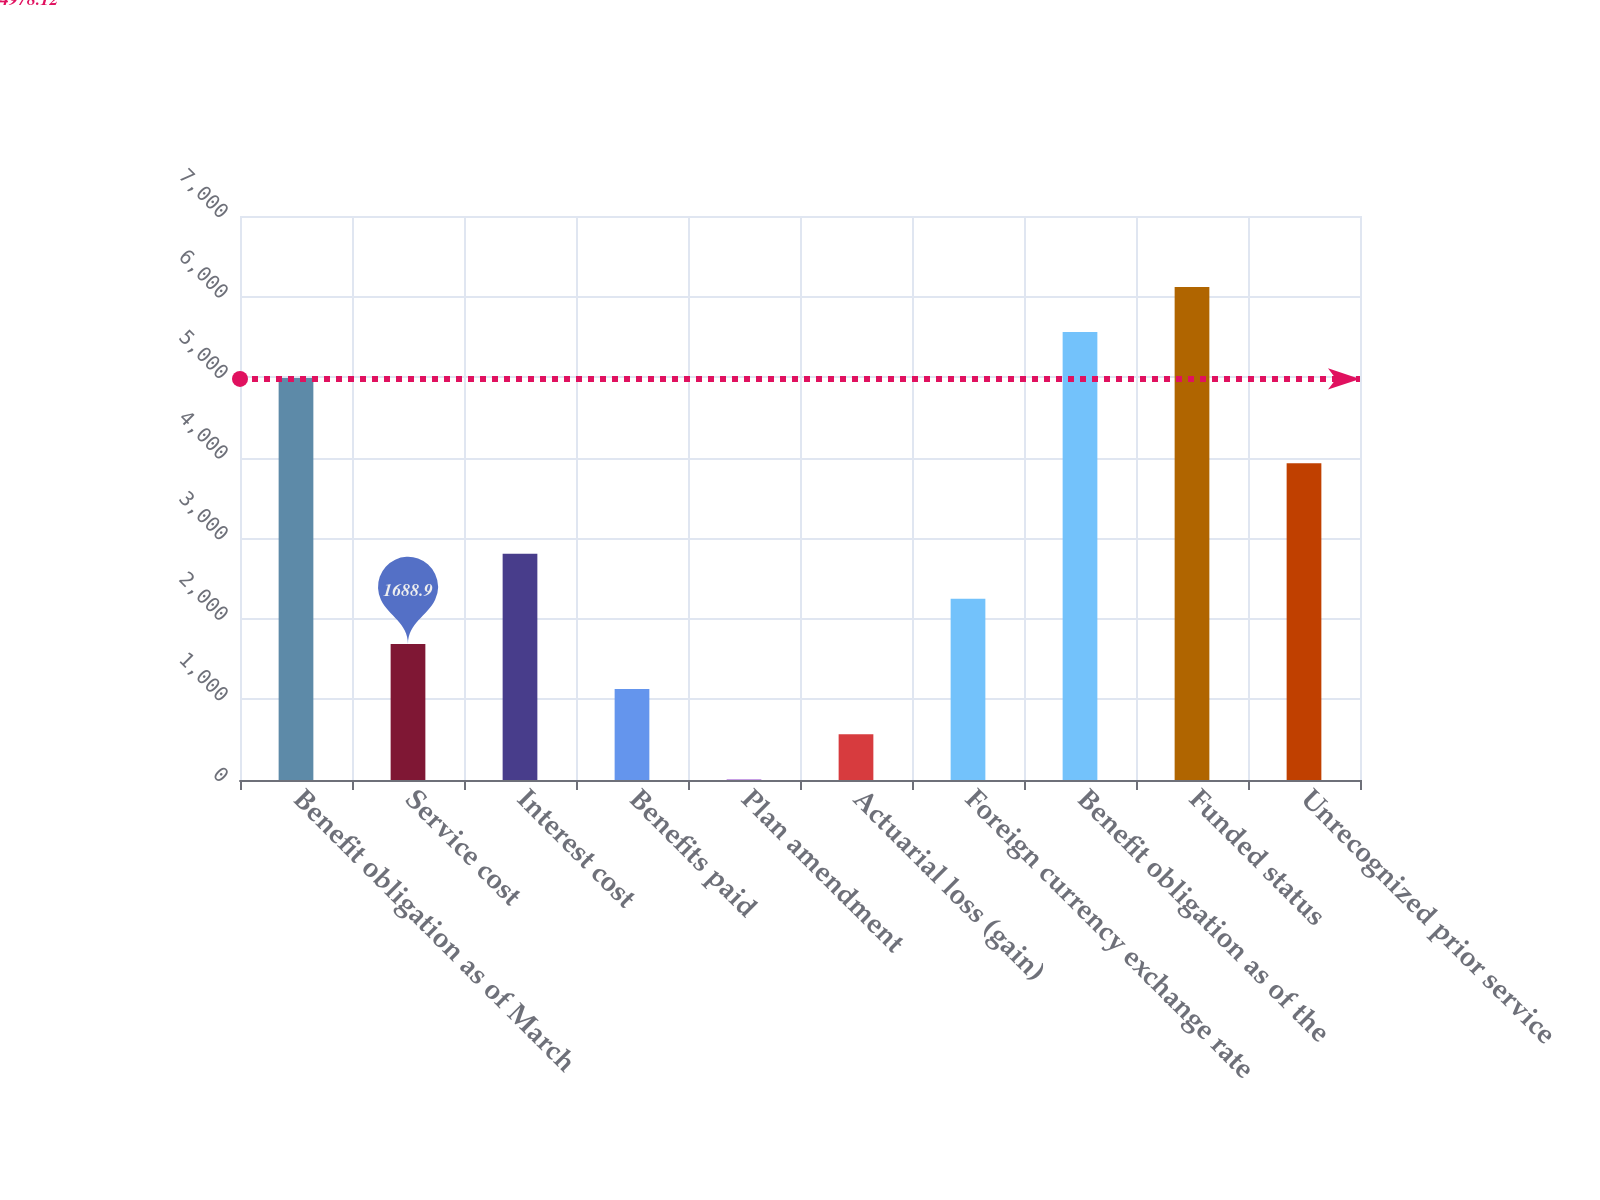Convert chart to OTSL. <chart><loc_0><loc_0><loc_500><loc_500><bar_chart><fcel>Benefit obligation as of March<fcel>Service cost<fcel>Interest cost<fcel>Benefits paid<fcel>Plan amendment<fcel>Actuarial loss (gain)<fcel>Foreign currency exchange rate<fcel>Benefit obligation as of the<fcel>Funded status<fcel>Unrecognized prior service<nl><fcel>4989<fcel>1688.9<fcel>2809.5<fcel>1128.6<fcel>8<fcel>568.3<fcel>2249.2<fcel>5560<fcel>6120.3<fcel>3930.1<nl></chart> 